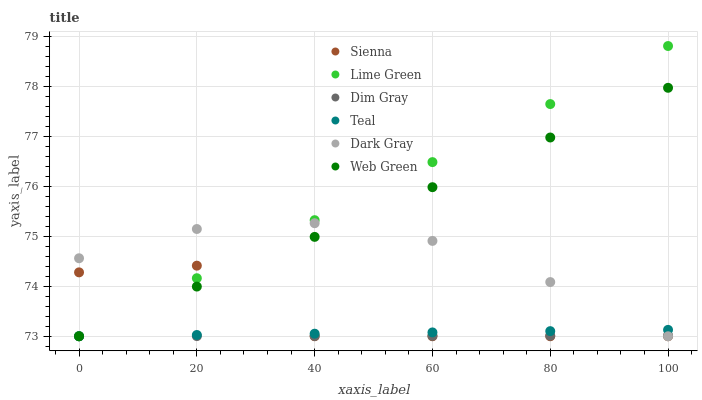Does Dim Gray have the minimum area under the curve?
Answer yes or no. Yes. Does Lime Green have the maximum area under the curve?
Answer yes or no. Yes. Does Web Green have the minimum area under the curve?
Answer yes or no. No. Does Web Green have the maximum area under the curve?
Answer yes or no. No. Is Dim Gray the smoothest?
Answer yes or no. Yes. Is Sienna the roughest?
Answer yes or no. Yes. Is Sienna the smoothest?
Answer yes or no. No. Is Web Green the roughest?
Answer yes or no. No. Does Dark Gray have the lowest value?
Answer yes or no. Yes. Does Lime Green have the highest value?
Answer yes or no. Yes. Does Web Green have the highest value?
Answer yes or no. No. Does Lime Green intersect Sienna?
Answer yes or no. Yes. Is Lime Green less than Sienna?
Answer yes or no. No. Is Lime Green greater than Sienna?
Answer yes or no. No. 